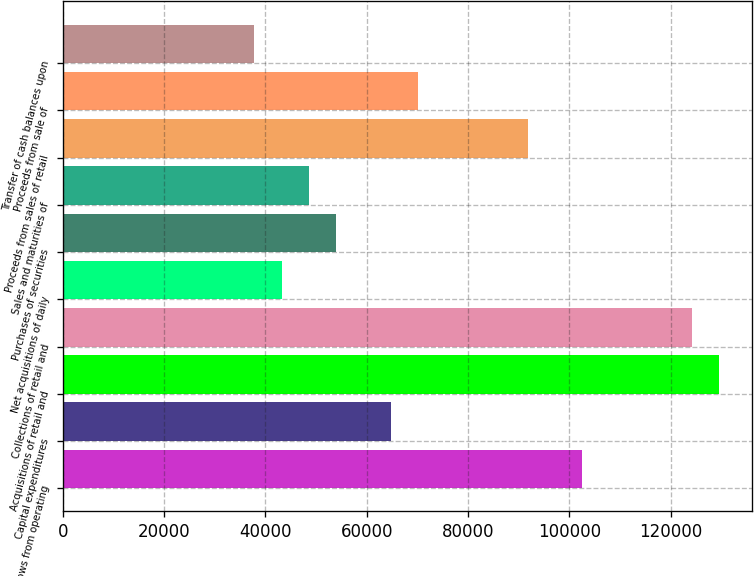Convert chart. <chart><loc_0><loc_0><loc_500><loc_500><bar_chart><fcel>Net cash flows from operating<fcel>Capital expenditures<fcel>Acquisitions of retail and<fcel>Collections of retail and<fcel>Net acquisitions of daily<fcel>Purchases of securities<fcel>Sales and maturities of<fcel>Proceeds from sales of retail<fcel>Proceeds from sale of<fcel>Transfer of cash balances upon<nl><fcel>102602<fcel>64819<fcel>129589<fcel>124192<fcel>43229<fcel>54024<fcel>48626.5<fcel>91806.5<fcel>70216.5<fcel>37831.5<nl></chart> 